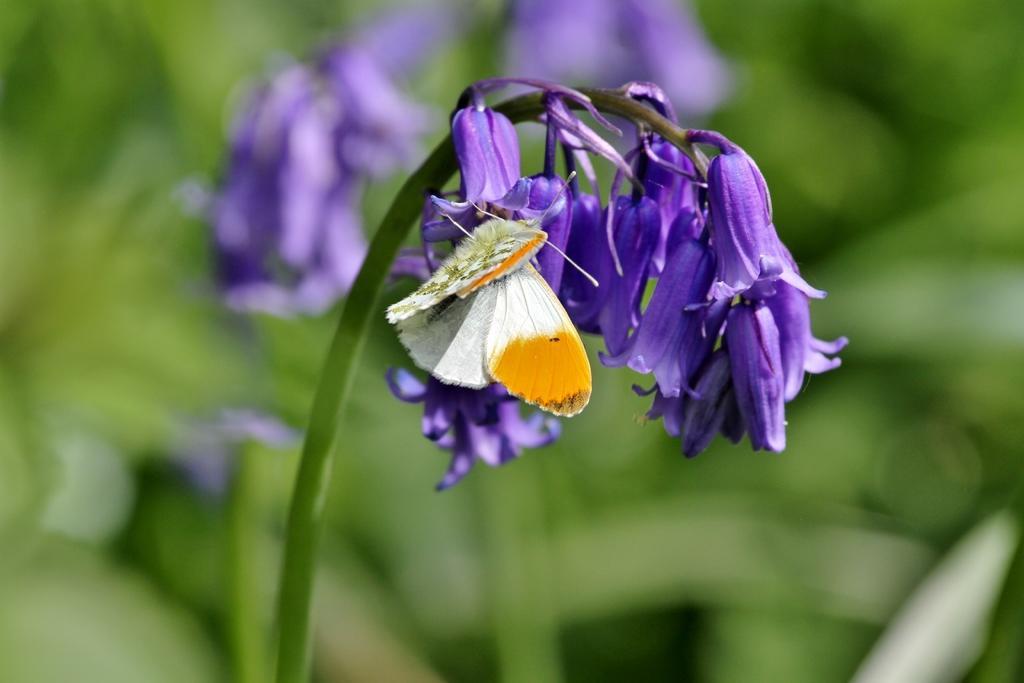What color are the flowers on the plant in the image? The flowers on the plant are purple. Is there anything else present on the flowers in the image? Yes, there is a butterfly on one of the flowers. Can you describe the background of the image? The background of the image is blurry. Where is the faucet located in the image? There is no faucet present in the image. What type of stick can be seen in the image? There is no stick present in the image. 